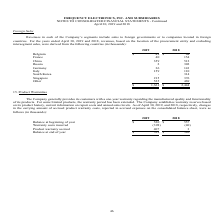From Frequency Electronics's financial document, What is the beginning balance in 2019 and 2018 respectively? The document shows two values: $520 and $557 (in thousands). From the document: "usands): 2019 2018 Balance at beginning of year $ 520 $ 557 ): 2019 2018 Balance at beginning of year $ 520 $ 557..." Also, What is the ending balance in 2019 and 2018 respectively? The document shows two values: $529 and $520 (in thousands). From the document: "usands): 2019 2018 Balance at beginning of year $ 520 $ 557 t warranty accrual 407 3 Balance at end of year $ 529 $ 520..." Also, How does the company establish warranty reserves? based on its product history, current information on repair costs and annual sales levels. The document states: "tended. The Company establishes warranty reserves based on its product history, current information on repair costs and annual sales levels. As of Apr..." Also, can you calculate: What is the change in beginning balance between 2018 and 2019? Based on the calculation: 520-557, the result is -37 (in thousands). This is based on the information: "): 2019 2018 Balance at beginning of year $ 520 $ 557 usands): 2019 2018 Balance at beginning of year $ 520 $ 557..." The key data points involved are: 520, 557. Also, can you calculate: What is the total warranty costs incurred in 2018 and 2019 altogether? Based on the calculation: 398+40, the result is 438 (in thousands). This is based on the information: "Warranty costs incurred (398 ) (40) Product warranty accrual 407 3 Balance at end of year $ 529 $ 520 France 40 154 China 359 512 Russia 2 302 Germany 36 143 Italy 159 110 South Korea - 314 Singapore ..." The key data points involved are: 398, 40. Additionally, Which year has a higher ending balance? According to the financial document, 2019. The relevant text states: "IDATED FINANCIAL STATEMENTS - Continued April 30, 2019 and 2018 Foreign Sales Revenues in each of the Company’s segments include sales to foreign governme..." 